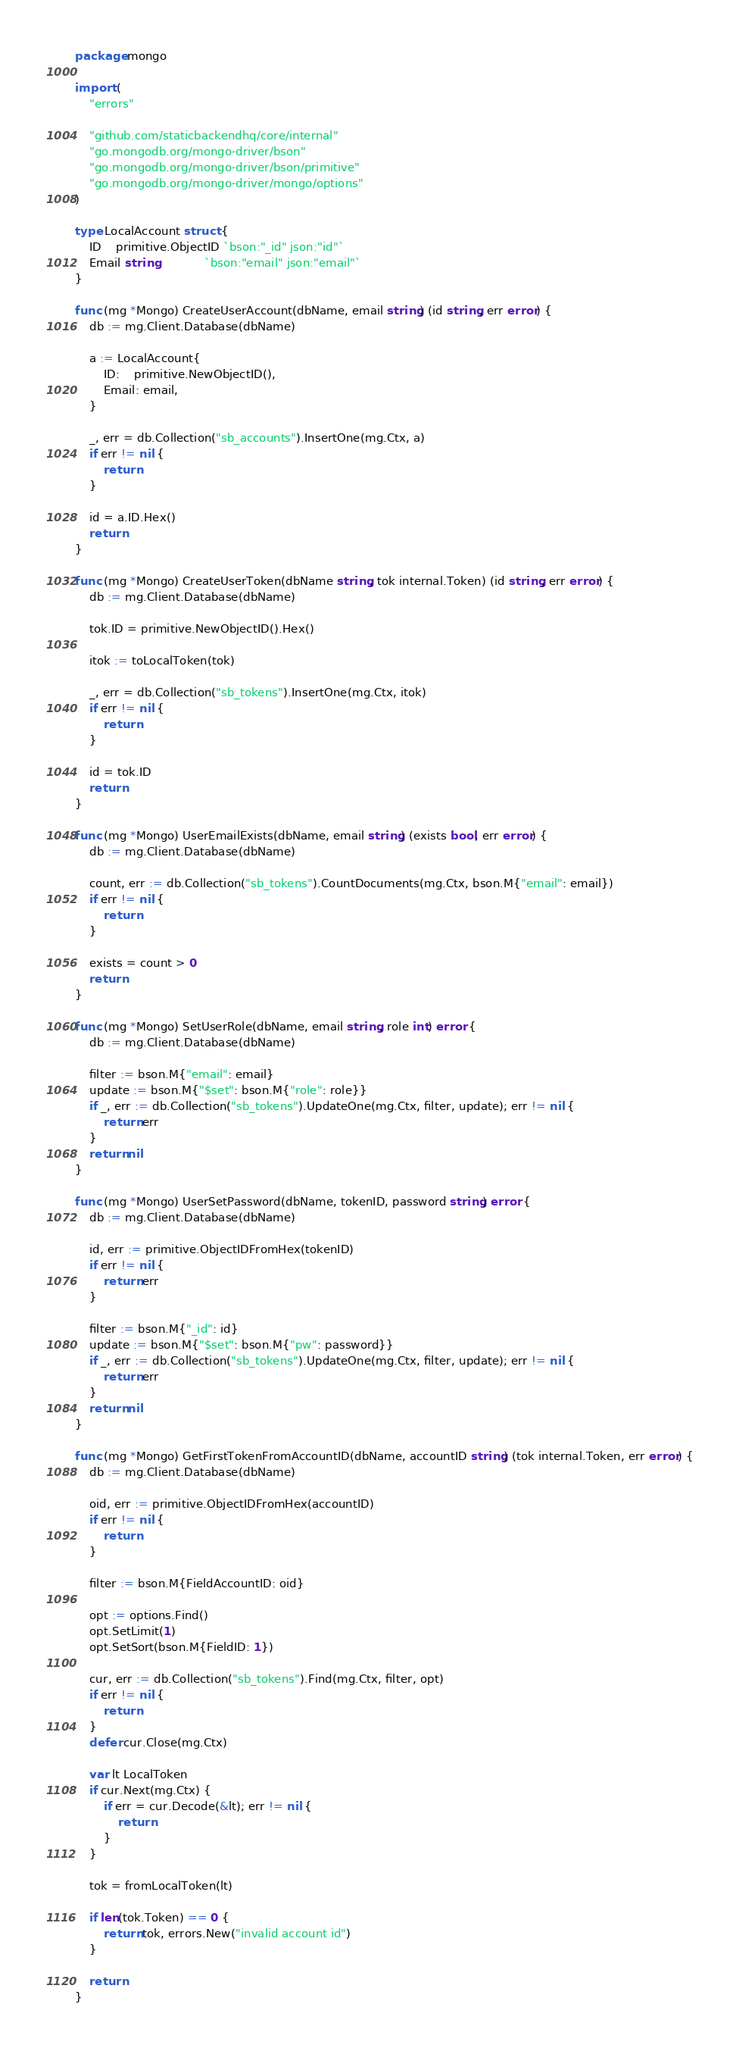Convert code to text. <code><loc_0><loc_0><loc_500><loc_500><_Go_>package mongo

import (
	"errors"

	"github.com/staticbackendhq/core/internal"
	"go.mongodb.org/mongo-driver/bson"
	"go.mongodb.org/mongo-driver/bson/primitive"
	"go.mongodb.org/mongo-driver/mongo/options"
)

type LocalAccount struct {
	ID    primitive.ObjectID `bson:"_id" json:"id"`
	Email string             `bson:"email" json:"email"`
}

func (mg *Mongo) CreateUserAccount(dbName, email string) (id string, err error) {
	db := mg.Client.Database(dbName)

	a := LocalAccount{
		ID:    primitive.NewObjectID(),
		Email: email,
	}

	_, err = db.Collection("sb_accounts").InsertOne(mg.Ctx, a)
	if err != nil {
		return
	}

	id = a.ID.Hex()
	return
}

func (mg *Mongo) CreateUserToken(dbName string, tok internal.Token) (id string, err error) {
	db := mg.Client.Database(dbName)

	tok.ID = primitive.NewObjectID().Hex()

	itok := toLocalToken(tok)

	_, err = db.Collection("sb_tokens").InsertOne(mg.Ctx, itok)
	if err != nil {
		return
	}

	id = tok.ID
	return
}

func (mg *Mongo) UserEmailExists(dbName, email string) (exists bool, err error) {
	db := mg.Client.Database(dbName)

	count, err := db.Collection("sb_tokens").CountDocuments(mg.Ctx, bson.M{"email": email})
	if err != nil {
		return
	}

	exists = count > 0
	return
}

func (mg *Mongo) SetUserRole(dbName, email string, role int) error {
	db := mg.Client.Database(dbName)

	filter := bson.M{"email": email}
	update := bson.M{"$set": bson.M{"role": role}}
	if _, err := db.Collection("sb_tokens").UpdateOne(mg.Ctx, filter, update); err != nil {
		return err
	}
	return nil
}

func (mg *Mongo) UserSetPassword(dbName, tokenID, password string) error {
	db := mg.Client.Database(dbName)

	id, err := primitive.ObjectIDFromHex(tokenID)
	if err != nil {
		return err
	}

	filter := bson.M{"_id": id}
	update := bson.M{"$set": bson.M{"pw": password}}
	if _, err := db.Collection("sb_tokens").UpdateOne(mg.Ctx, filter, update); err != nil {
		return err
	}
	return nil
}

func (mg *Mongo) GetFirstTokenFromAccountID(dbName, accountID string) (tok internal.Token, err error) {
	db := mg.Client.Database(dbName)

	oid, err := primitive.ObjectIDFromHex(accountID)
	if err != nil {
		return
	}

	filter := bson.M{FieldAccountID: oid}

	opt := options.Find()
	opt.SetLimit(1)
	opt.SetSort(bson.M{FieldID: 1})

	cur, err := db.Collection("sb_tokens").Find(mg.Ctx, filter, opt)
	if err != nil {
		return
	}
	defer cur.Close(mg.Ctx)

	var lt LocalToken
	if cur.Next(mg.Ctx) {
		if err = cur.Decode(&lt); err != nil {
			return
		}
	}

	tok = fromLocalToken(lt)

	if len(tok.Token) == 0 {
		return tok, errors.New("invalid account id")
	}

	return
}
</code> 